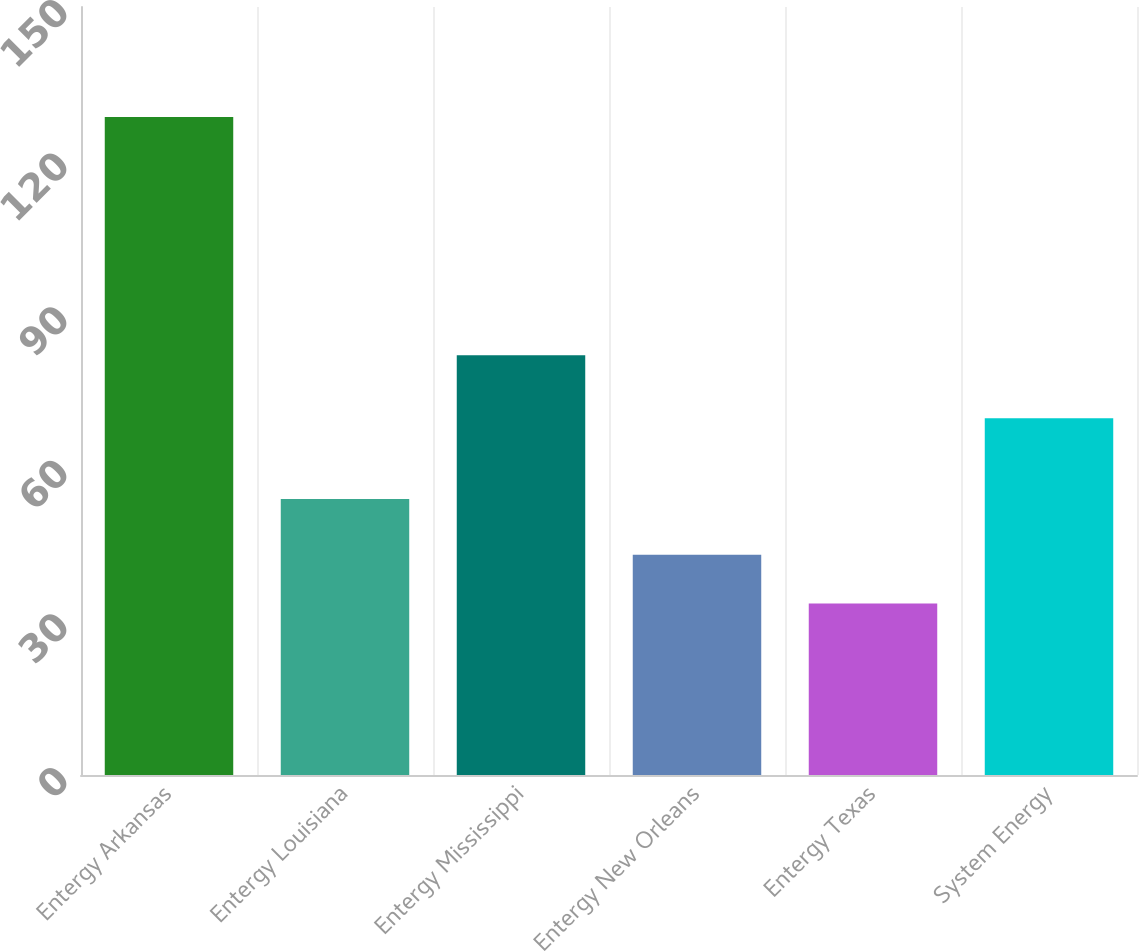<chart> <loc_0><loc_0><loc_500><loc_500><bar_chart><fcel>Entergy Arkansas<fcel>Entergy Louisiana<fcel>Entergy Mississippi<fcel>Entergy New Orleans<fcel>Entergy Texas<fcel>System Energy<nl><fcel>128.5<fcel>53.9<fcel>82<fcel>43<fcel>33.5<fcel>69.7<nl></chart> 